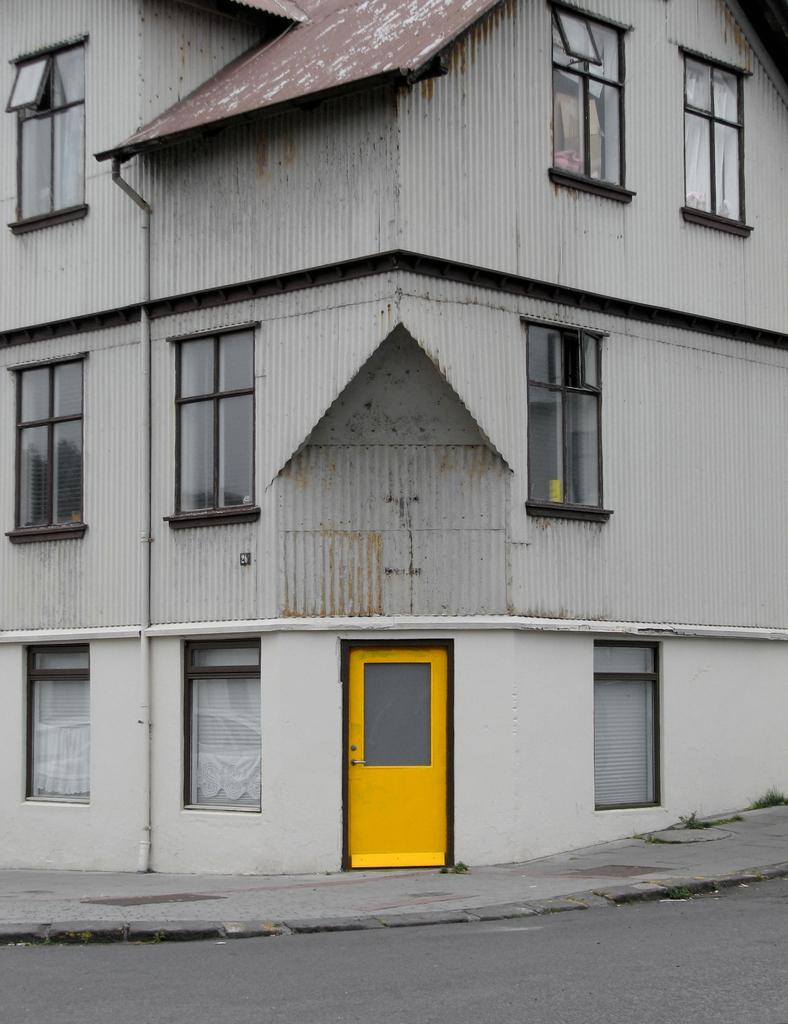What type of structure is present in the image? There is a building in the picture. What feature can be observed on the building? The building has glass windows. What is the color of the door on the building? The building has a yellow color door. What else can be seen in the image besides the building? There is a road visible in the picture. How many light bulbs are hanging from the ceiling in the image? There is no information about light bulbs in the image, as it only mentions the building, glass windows, yellow door, and road. 